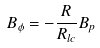<formula> <loc_0><loc_0><loc_500><loc_500>B _ { \phi } = - \frac { R } { R _ { l c } } B _ { p }</formula> 